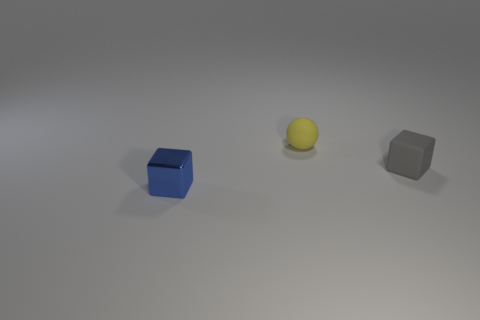Add 1 cubes. How many objects exist? 4 Subtract all gray blocks. How many blocks are left? 1 Add 1 gray matte things. How many gray matte things exist? 2 Subtract 0 green blocks. How many objects are left? 3 Subtract all balls. How many objects are left? 2 Subtract all purple cubes. Subtract all red spheres. How many cubes are left? 2 Subtract all small yellow things. Subtract all tiny gray matte things. How many objects are left? 1 Add 2 small gray things. How many small gray things are left? 3 